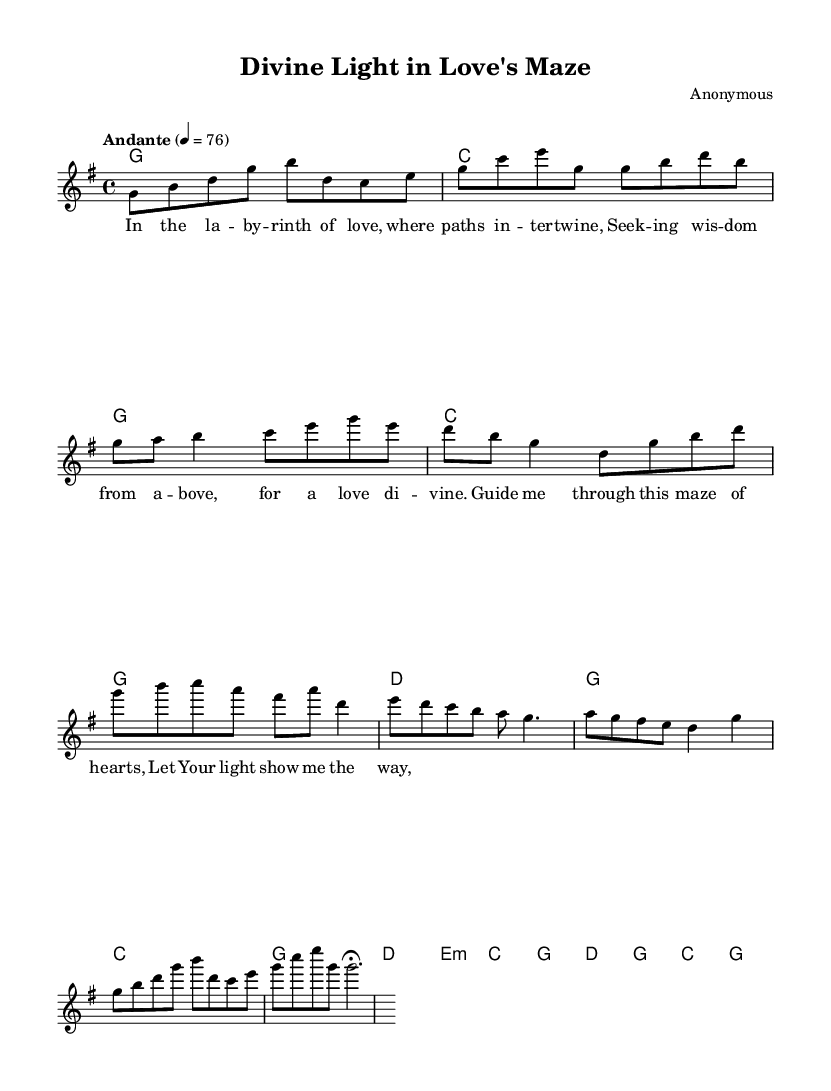What is the key signature of this music? The key signature is G major, which has one sharp (F#). This can be determined by examining the key signature located at the beginning of the sheet music.
Answer: G major What is the time signature of this music? The time signature is 4/4, as indicated in the initial measures of the sheet music. This means there are four beats in a measure, and the quarter note gets one beat.
Answer: 4/4 What is the indicated tempo of this piece? The tempo specified is Andante, with a marking of 76 beats per minute. This is shown just above the staff where the tempo indications are commonly located.
Answer: Andante, 76 How many measures are in the verse section? The verse section contains four measures, which can be counted directly from the provided melody lines under the verse lyrics.
Answer: Four What is the first chord played in the music? The first chord played is G major, as seen at the start of the chord section, indicated by the G symbol and held for the duration of a whole note.
Answer: G major What thematic element is emphasized in the chorus? The thematic element emphasized in the chorus is guidance, as the lyrics speak to being guided through a maze, indicating a search for direction in love. This can be noted from analyzing the content of the lyrics of the chorus section.
Answer: Guidance 